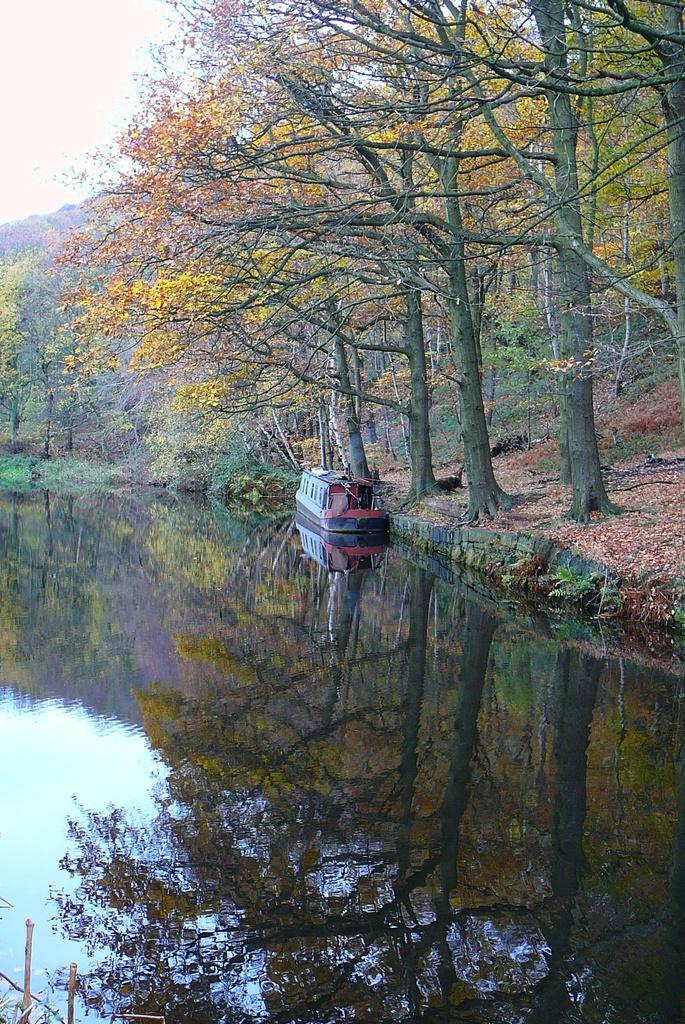What is the main subject of the image? The main subject of the image is a boat. Where is the boat located? The boat is on the water. What can be seen in the background of the image? There are trees and the sky visible in the background of the image. What type of company is performing on the stage in the image? There is no stage or company present in the image; it features a boat on the water with trees and the sky in the background. 